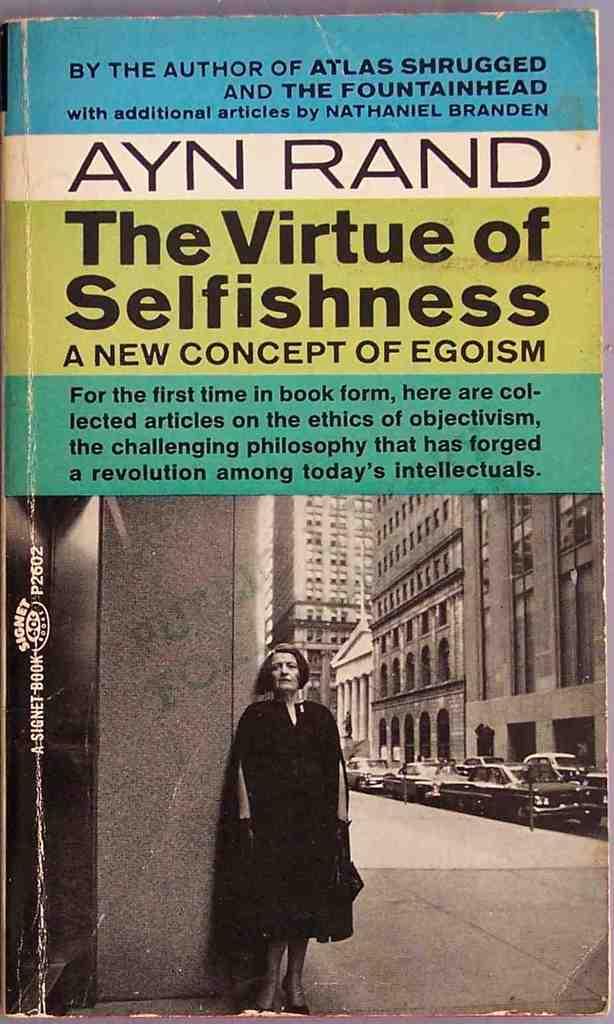What is the title of the book?
Provide a short and direct response. The virtue of selfishness. 